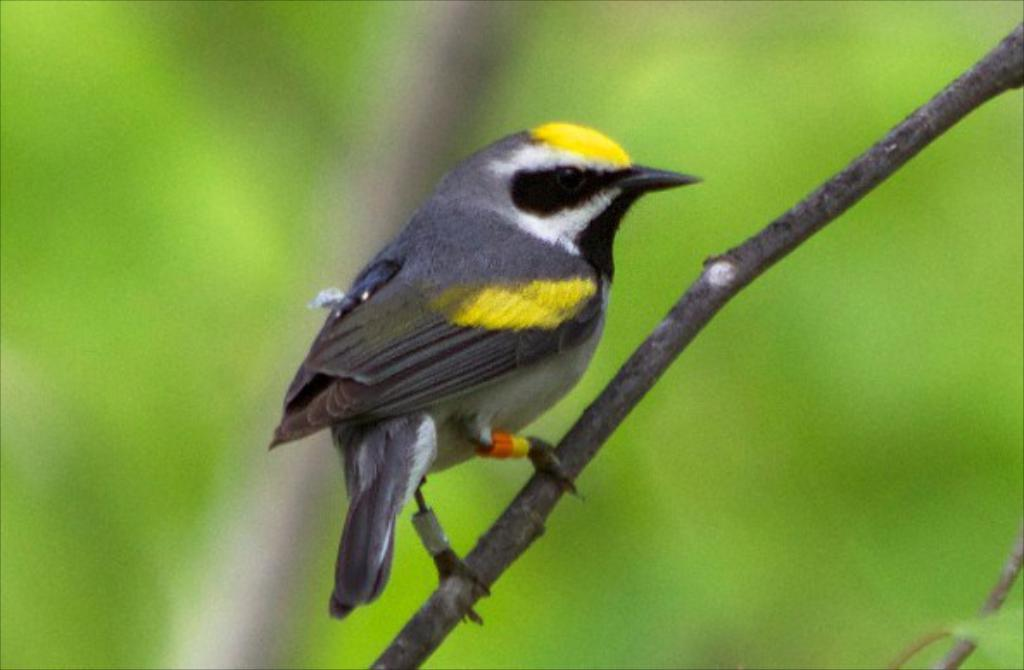What type of animal is in the image? There is a bird in the image. What colors can be seen on the bird? The bird has yellow and grey colors. Can you describe the background of the image? The background of the image is blurred. What type of attraction is the bird visiting in the image? There is no indication of an attraction in the image; it simply features a bird with yellow and grey colors against a blurred background. 